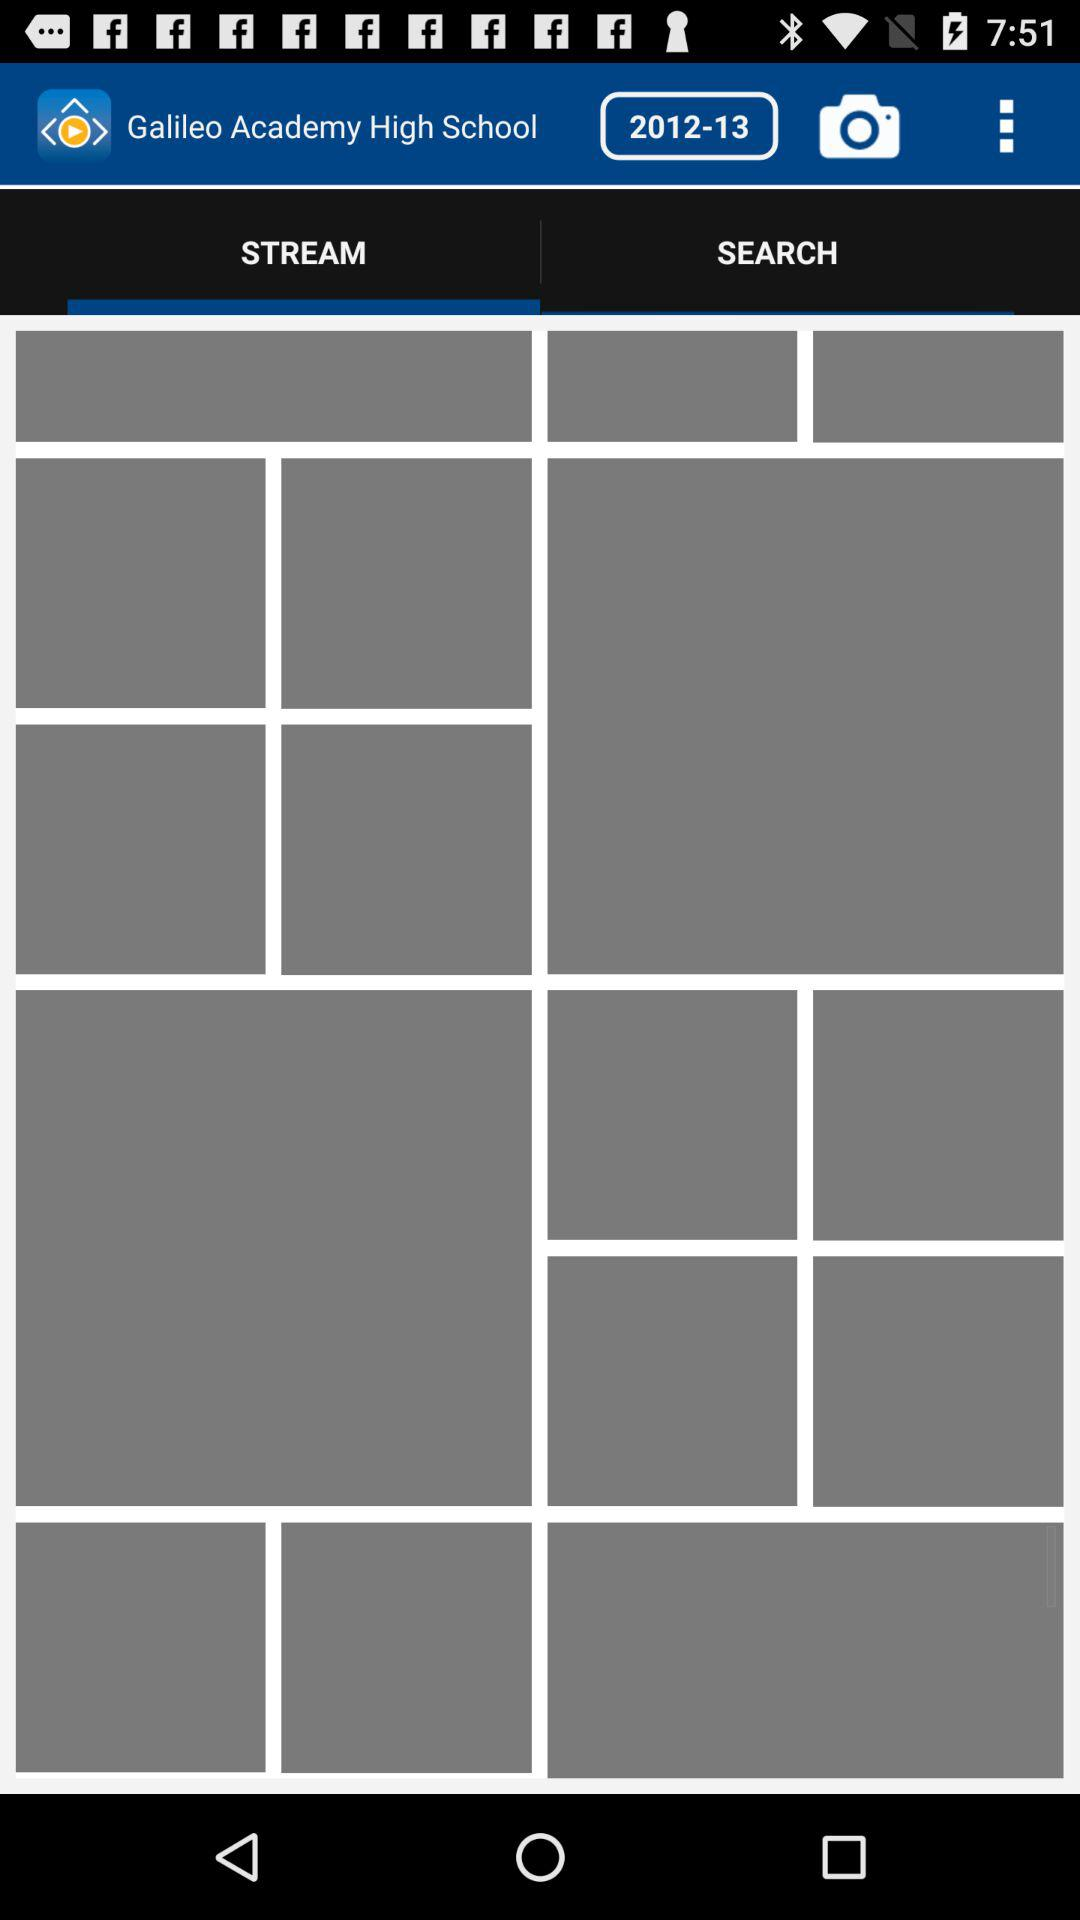What's the mentioned academic year of "Galileo Academy High School"? The mentioned academic year is 2012-13. 